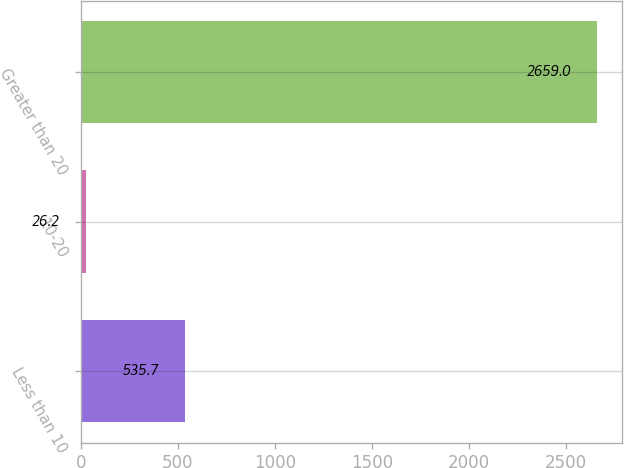Convert chart. <chart><loc_0><loc_0><loc_500><loc_500><bar_chart><fcel>Less than 10<fcel>10-20<fcel>Greater than 20<nl><fcel>535.7<fcel>26.2<fcel>2659<nl></chart> 